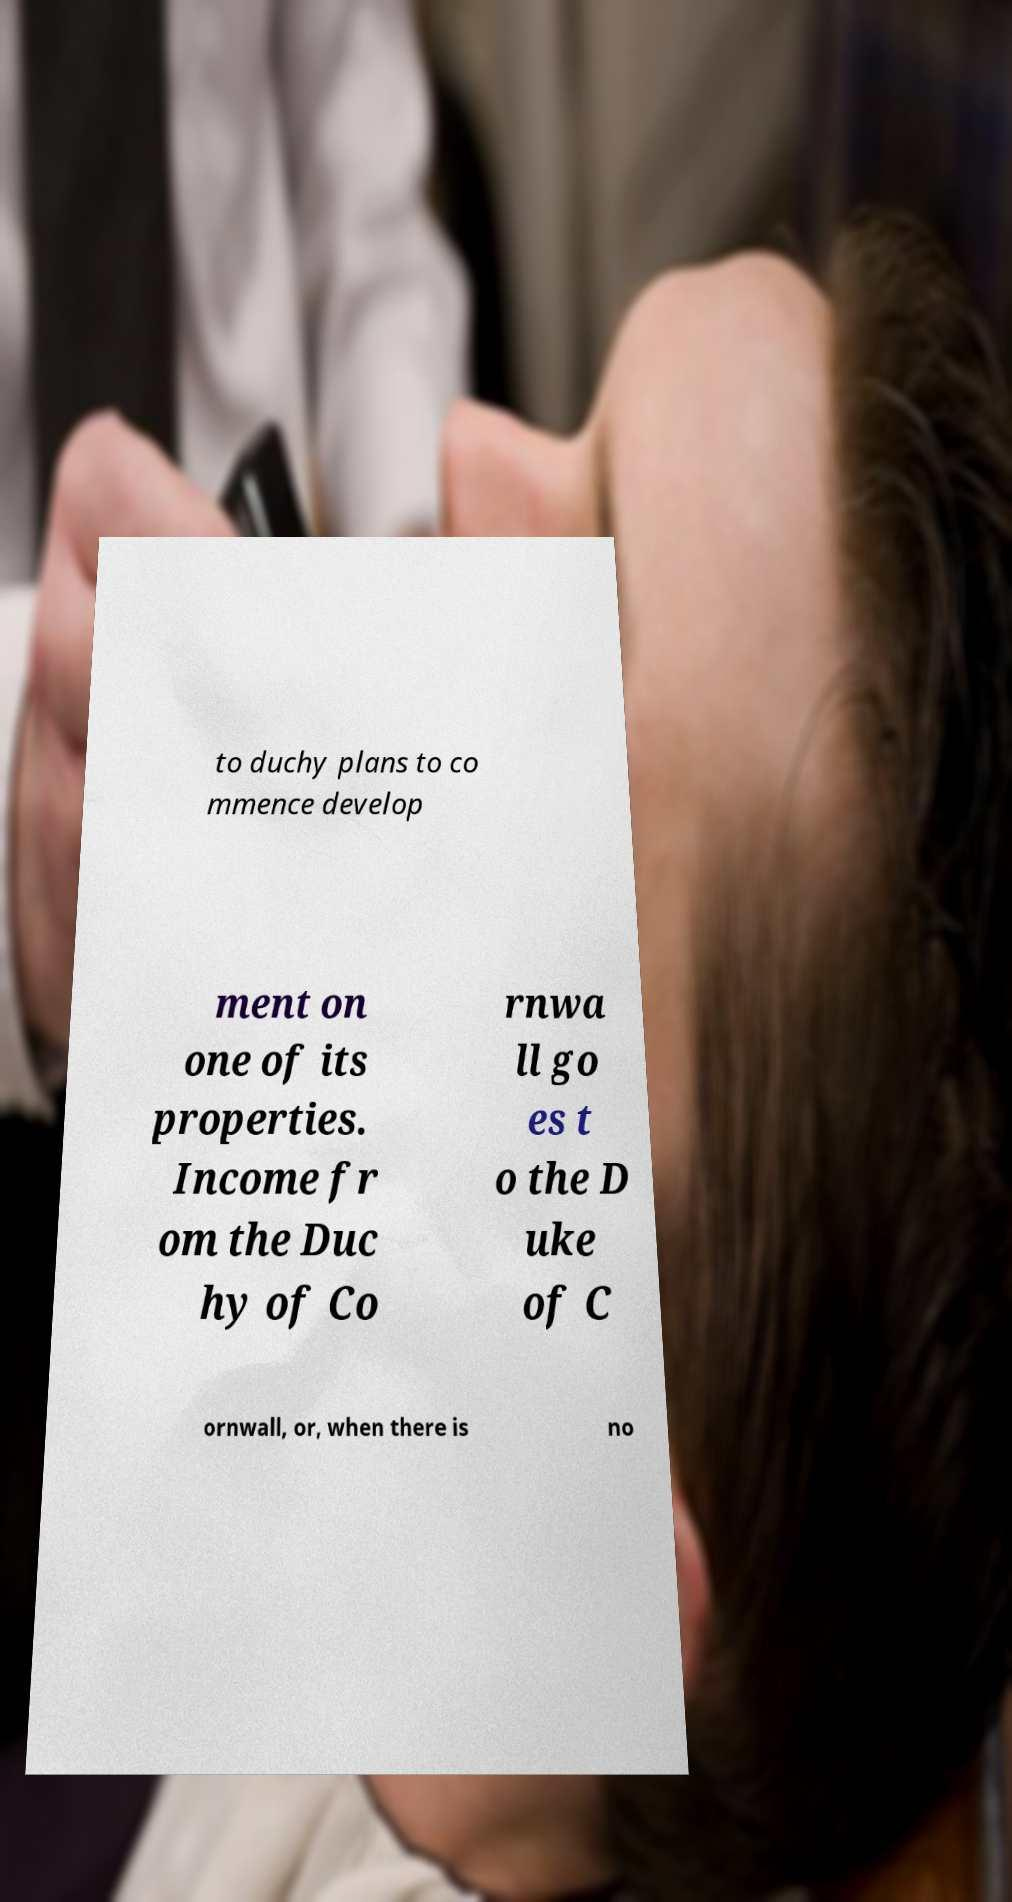Please read and relay the text visible in this image. What does it say? to duchy plans to co mmence develop ment on one of its properties. Income fr om the Duc hy of Co rnwa ll go es t o the D uke of C ornwall, or, when there is no 